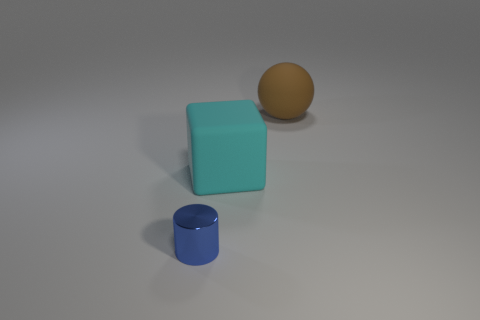Add 1 tiny cylinders. How many objects exist? 4 Subtract all cylinders. How many objects are left? 2 Add 3 tiny metal objects. How many tiny metal objects are left? 4 Add 2 spheres. How many spheres exist? 3 Subtract 0 gray cylinders. How many objects are left? 3 Subtract all big brown balls. Subtract all tiny green things. How many objects are left? 2 